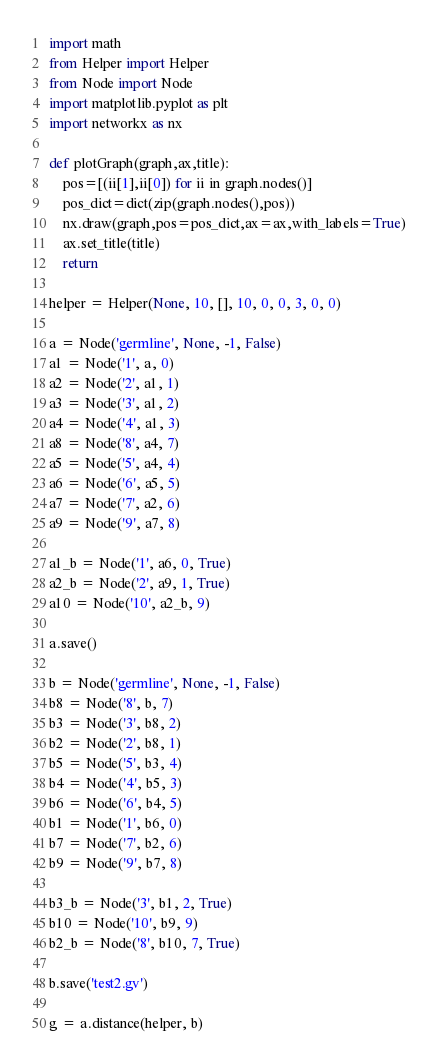<code> <loc_0><loc_0><loc_500><loc_500><_Python_>import math
from Helper import Helper
from Node import Node
import matplotlib.pyplot as plt
import networkx as nx

def plotGraph(graph,ax,title):
    pos=[(ii[1],ii[0]) for ii in graph.nodes()]
    pos_dict=dict(zip(graph.nodes(),pos))
    nx.draw(graph,pos=pos_dict,ax=ax,with_labels=True)
    ax.set_title(title)
    return

helper = Helper(None, 10, [], 10, 0, 0, 3, 0, 0)

a = Node('germline', None, -1, False)
a1 = Node('1', a, 0)
a2 = Node('2', a1, 1)
a3 = Node('3', a1, 2)
a4 = Node('4', a1, 3)
a8 = Node('8', a4, 7)
a5 = Node('5', a4, 4)
a6 = Node('6', a5, 5)
a7 = Node('7', a2, 6)
a9 = Node('9', a7, 8)

a1_b = Node('1', a6, 0, True)
a2_b = Node('2', a9, 1, True)
a10 = Node('10', a2_b, 9)

a.save()

b = Node('germline', None, -1, False)
b8 = Node('8', b, 7)
b3 = Node('3', b8, 2)
b2 = Node('2', b8, 1)
b5 = Node('5', b3, 4)
b4 = Node('4', b5, 3)
b6 = Node('6', b4, 5)
b1 = Node('1', b6, 0)
b7 = Node('7', b2, 6)
b9 = Node('9', b7, 8)

b3_b = Node('3', b1, 2, True)
b10 = Node('10', b9, 9)
b2_b = Node('8', b10, 7, True)

b.save('test2.gv')

g = a.distance(helper, b)
</code> 